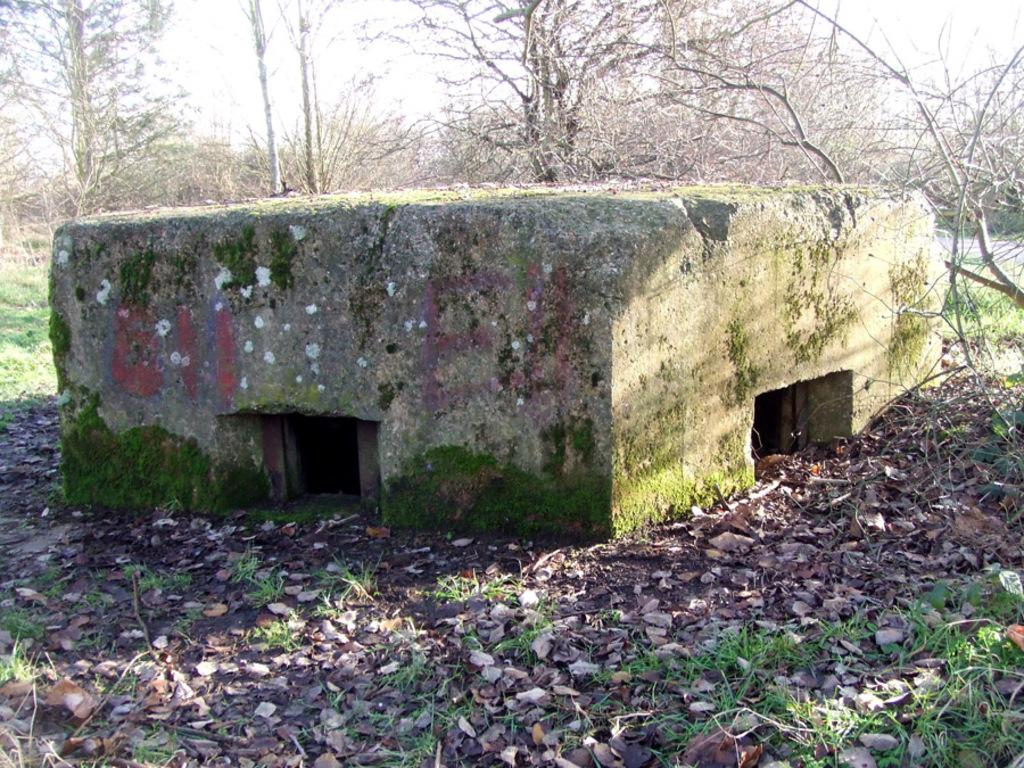What is the main subject in the foreground of the image? There is a cement structure in the foreground of the image. Where is the cement structure located in the image? The cement structure is in the middle of the image. What can be seen in the background of the image? There are trees and the sky visible in the background of the image. What type of scent can be detected from the jellyfish in the image? There are no jellyfish present in the image, so it is not possible to detect any scent from them. 